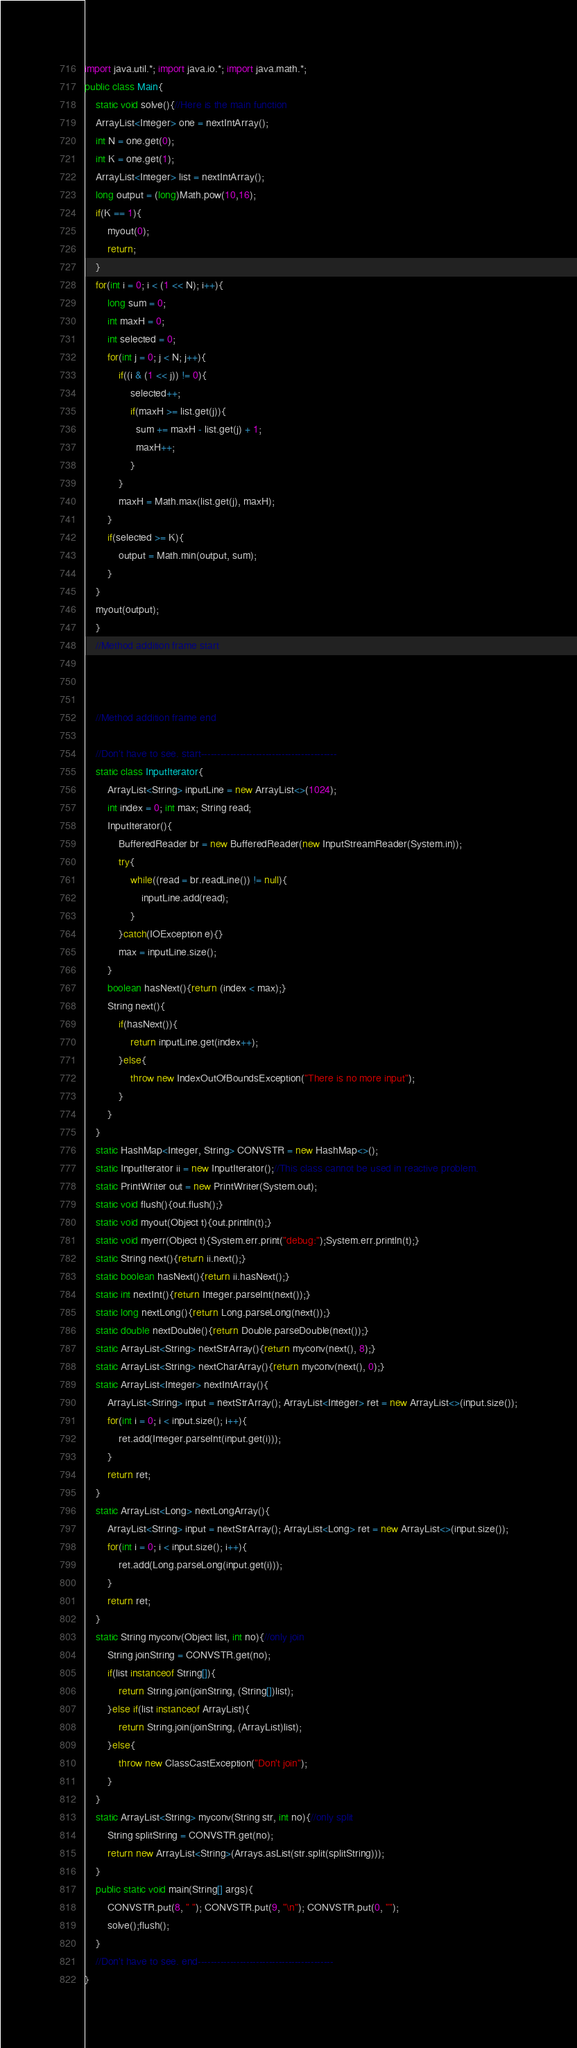Convert code to text. <code><loc_0><loc_0><loc_500><loc_500><_Java_>import java.util.*; import java.io.*; import java.math.*;
public class Main{
	static void solve(){//Here is the main function
	ArrayList<Integer> one = nextIntArray();
	int N = one.get(0);
	int K = one.get(1);
	ArrayList<Integer> list = nextIntArray();
	long output = (long)Math.pow(10,16);
	if(K == 1){
		myout(0);
		return;
	}
	for(int i = 0; i < (1 << N); i++){
		long sum = 0;
        int maxH = 0;
        int selected = 0;
		for(int j = 0; j < N; j++){
			if((i & (1 << j)) != 0){
                selected++;
				if(maxH >= list.get(j)){
                  sum += maxH - list.get(j) + 1;
                  maxH++;
                }
			}
            maxH = Math.max(list.get(j), maxH);
		}
		if(selected >= K){
			output = Math.min(output, sum);
		}
	}
	myout(output);
	}
	//Method addition frame start



	//Method addition frame end

	//Don't have to see. start------------------------------------------
	static class InputIterator{
		ArrayList<String> inputLine = new ArrayList<>(1024);
		int index = 0; int max; String read;
		InputIterator(){
			BufferedReader br = new BufferedReader(new InputStreamReader(System.in));
			try{
				while((read = br.readLine()) != null){
					inputLine.add(read);
				}
			}catch(IOException e){}
			max = inputLine.size();
		}
		boolean hasNext(){return (index < max);}
		String next(){
			if(hasNext()){
				return inputLine.get(index++);
			}else{
				throw new IndexOutOfBoundsException("There is no more input");
			}
		}
	}
	static HashMap<Integer, String> CONVSTR = new HashMap<>();
	static InputIterator ii = new InputIterator();//This class cannot be used in reactive problem.
	static PrintWriter out = new PrintWriter(System.out);
	static void flush(){out.flush();}
	static void myout(Object t){out.println(t);}
	static void myerr(Object t){System.err.print("debug:");System.err.println(t);}
	static String next(){return ii.next();}
	static boolean hasNext(){return ii.hasNext();}
	static int nextInt(){return Integer.parseInt(next());}
	static long nextLong(){return Long.parseLong(next());}
	static double nextDouble(){return Double.parseDouble(next());}
	static ArrayList<String> nextStrArray(){return myconv(next(), 8);}
	static ArrayList<String> nextCharArray(){return myconv(next(), 0);}
	static ArrayList<Integer> nextIntArray(){
		ArrayList<String> input = nextStrArray(); ArrayList<Integer> ret = new ArrayList<>(input.size());
		for(int i = 0; i < input.size(); i++){
			ret.add(Integer.parseInt(input.get(i)));
		}
		return ret;
	}
	static ArrayList<Long> nextLongArray(){
		ArrayList<String> input = nextStrArray(); ArrayList<Long> ret = new ArrayList<>(input.size());
		for(int i = 0; i < input.size(); i++){
			ret.add(Long.parseLong(input.get(i)));
		}
		return ret;
	}
	static String myconv(Object list, int no){//only join
		String joinString = CONVSTR.get(no);
		if(list instanceof String[]){
			return String.join(joinString, (String[])list);
		}else if(list instanceof ArrayList){
			return String.join(joinString, (ArrayList)list);
		}else{
			throw new ClassCastException("Don't join");
		}
	}
	static ArrayList<String> myconv(String str, int no){//only split
		String splitString = CONVSTR.get(no);
		return new ArrayList<String>(Arrays.asList(str.split(splitString)));
	}
	public static void main(String[] args){
		CONVSTR.put(8, " "); CONVSTR.put(9, "\n"); CONVSTR.put(0, "");
		solve();flush();
	}
	//Don't have to see. end------------------------------------------
}
</code> 